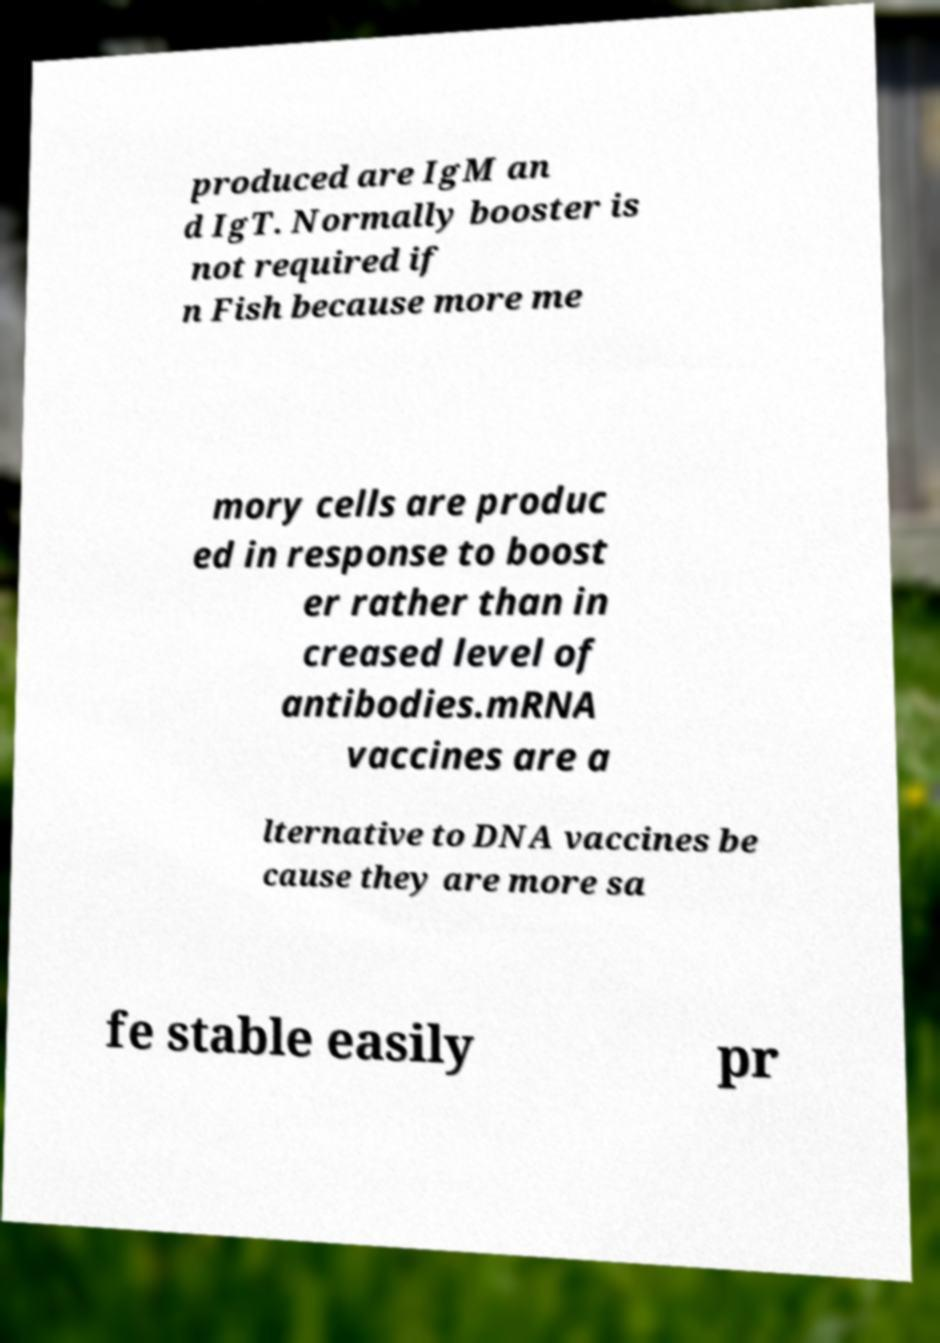Please identify and transcribe the text found in this image. produced are IgM an d IgT. Normally booster is not required if n Fish because more me mory cells are produc ed in response to boost er rather than in creased level of antibodies.mRNA vaccines are a lternative to DNA vaccines be cause they are more sa fe stable easily pr 